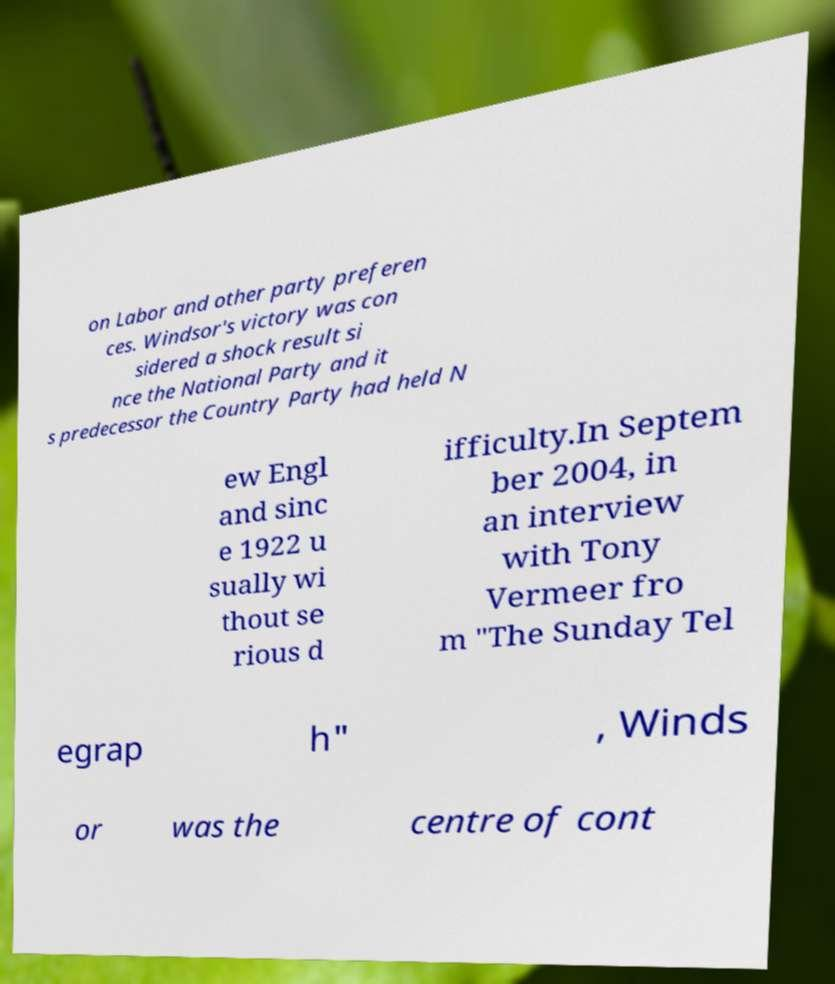Can you read and provide the text displayed in the image?This photo seems to have some interesting text. Can you extract and type it out for me? on Labor and other party preferen ces. Windsor's victory was con sidered a shock result si nce the National Party and it s predecessor the Country Party had held N ew Engl and sinc e 1922 u sually wi thout se rious d ifficulty.In Septem ber 2004, in an interview with Tony Vermeer fro m "The Sunday Tel egrap h" , Winds or was the centre of cont 